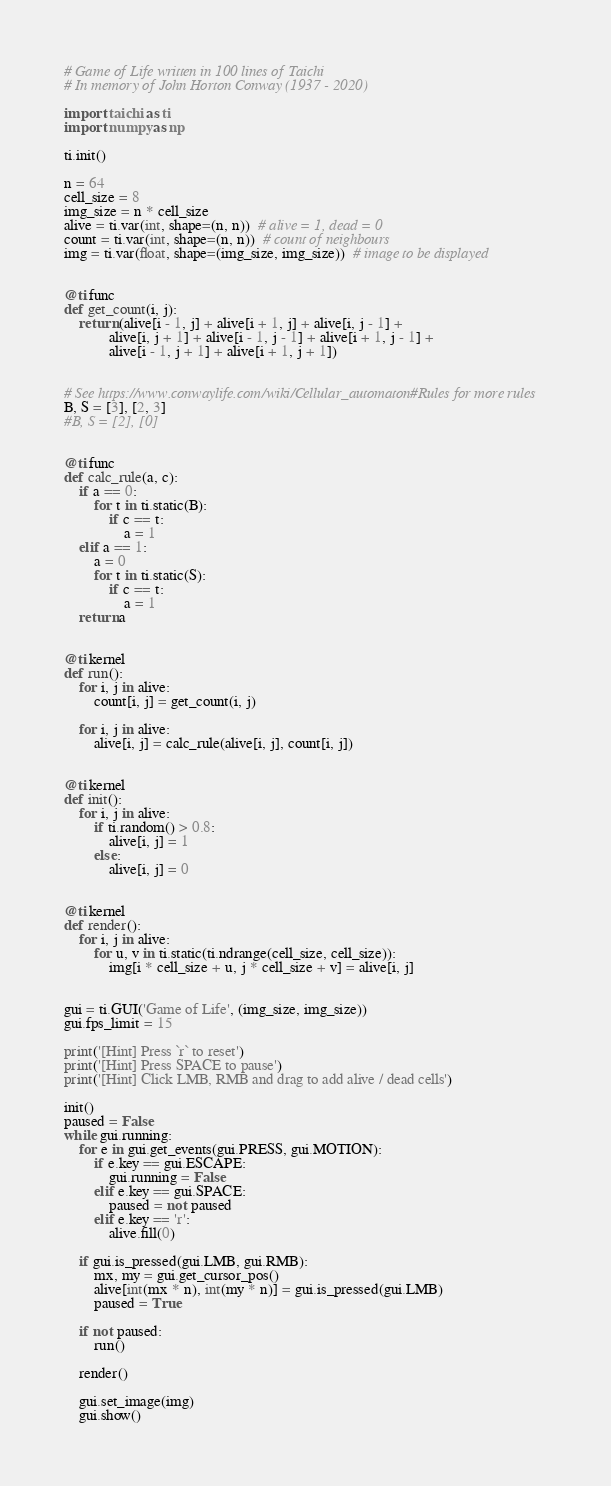Convert code to text. <code><loc_0><loc_0><loc_500><loc_500><_Python_># Game of Life written in 100 lines of Taichi
# In memory of John Horton Conway (1937 - 2020)

import taichi as ti
import numpy as np

ti.init()

n = 64
cell_size = 8
img_size = n * cell_size
alive = ti.var(int, shape=(n, n))  # alive = 1, dead = 0
count = ti.var(int, shape=(n, n))  # count of neighbours
img = ti.var(float, shape=(img_size, img_size))  # image to be displayed


@ti.func
def get_count(i, j):
    return (alive[i - 1, j] + alive[i + 1, j] + alive[i, j - 1] +
            alive[i, j + 1] + alive[i - 1, j - 1] + alive[i + 1, j - 1] +
            alive[i - 1, j + 1] + alive[i + 1, j + 1])


# See https://www.conwaylife.com/wiki/Cellular_automaton#Rules for more rules
B, S = [3], [2, 3]
#B, S = [2], [0]


@ti.func
def calc_rule(a, c):
    if a == 0:
        for t in ti.static(B):
            if c == t:
                a = 1
    elif a == 1:
        a = 0
        for t in ti.static(S):
            if c == t:
                a = 1
    return a


@ti.kernel
def run():
    for i, j in alive:
        count[i, j] = get_count(i, j)

    for i, j in alive:
        alive[i, j] = calc_rule(alive[i, j], count[i, j])


@ti.kernel
def init():
    for i, j in alive:
        if ti.random() > 0.8:
            alive[i, j] = 1
        else:
            alive[i, j] = 0


@ti.kernel
def render():
    for i, j in alive:
        for u, v in ti.static(ti.ndrange(cell_size, cell_size)):
            img[i * cell_size + u, j * cell_size + v] = alive[i, j]


gui = ti.GUI('Game of Life', (img_size, img_size))
gui.fps_limit = 15

print('[Hint] Press `r` to reset')
print('[Hint] Press SPACE to pause')
print('[Hint] Click LMB, RMB and drag to add alive / dead cells')

init()
paused = False
while gui.running:
    for e in gui.get_events(gui.PRESS, gui.MOTION):
        if e.key == gui.ESCAPE:
            gui.running = False
        elif e.key == gui.SPACE:
            paused = not paused
        elif e.key == 'r':
            alive.fill(0)

    if gui.is_pressed(gui.LMB, gui.RMB):
        mx, my = gui.get_cursor_pos()
        alive[int(mx * n), int(my * n)] = gui.is_pressed(gui.LMB)
        paused = True

    if not paused:
        run()

    render()

    gui.set_image(img)
    gui.show()
</code> 